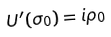<formula> <loc_0><loc_0><loc_500><loc_500>U ^ { \prime } ( \sigma _ { 0 } ) = i \rho _ { 0 }</formula> 